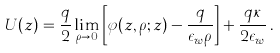Convert formula to latex. <formula><loc_0><loc_0><loc_500><loc_500>U ( z ) = \frac { q } { 2 } \lim _ { \rho \rightarrow 0 } \left [ \varphi ( z , \rho ; z ) - \frac { q } { \epsilon _ { w } \rho } \right ] + \frac { q \kappa } { 2 \epsilon _ { w } } \, .</formula> 